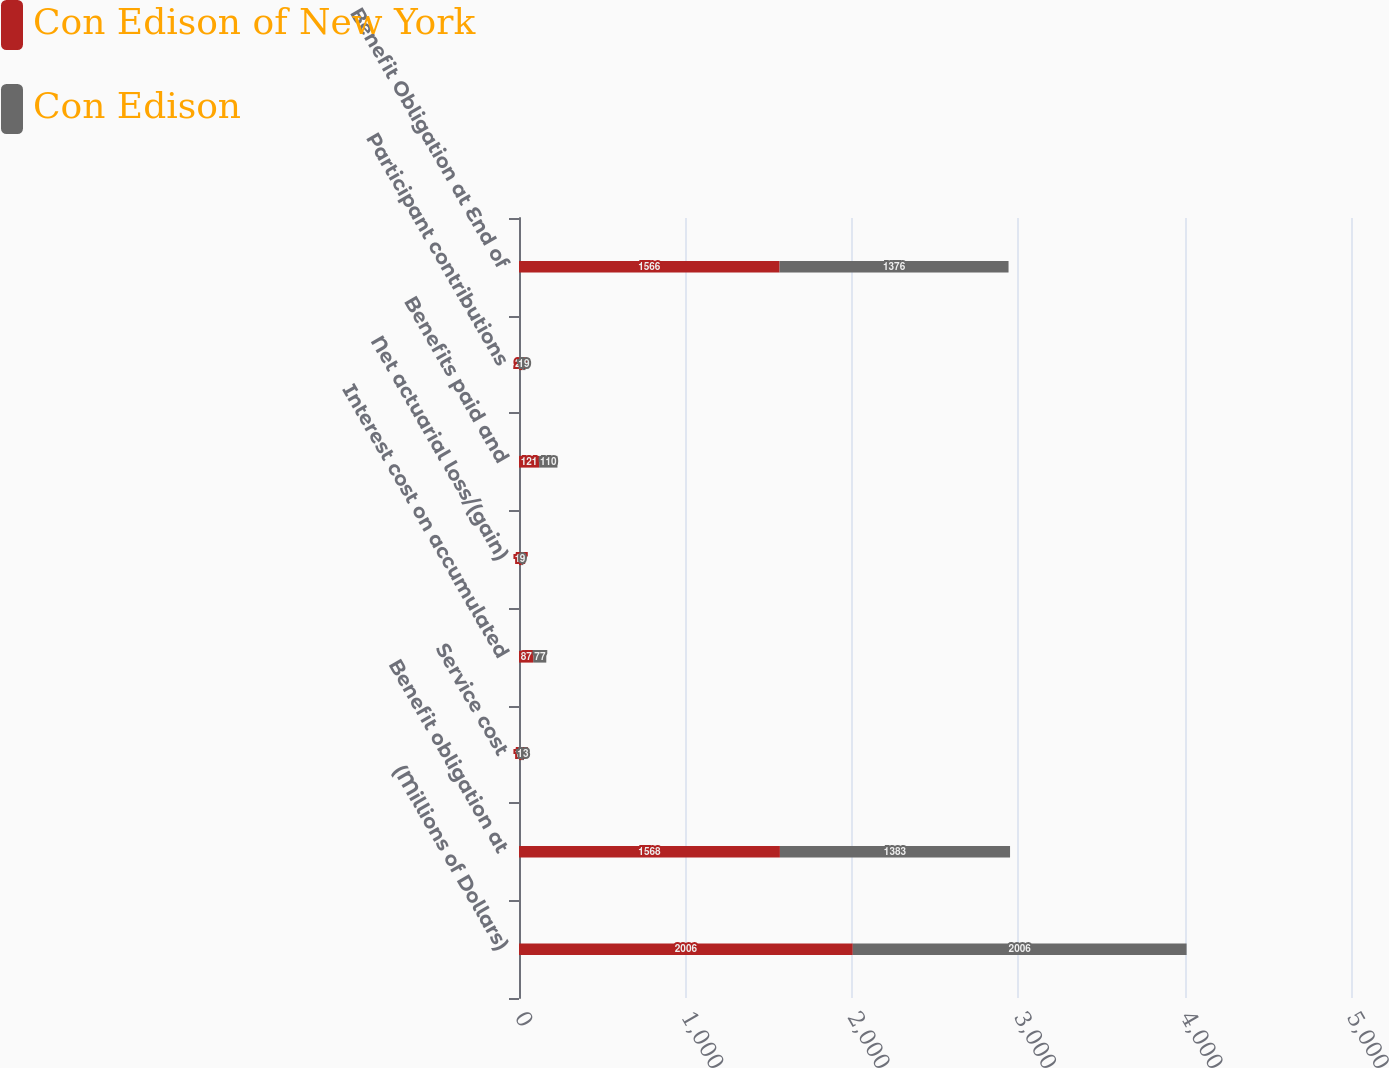<chart> <loc_0><loc_0><loc_500><loc_500><stacked_bar_chart><ecel><fcel>(Millions of Dollars)<fcel>Benefit obligation at<fcel>Service cost<fcel>Interest cost on accumulated<fcel>Net actuarial loss/(gain)<fcel>Benefits paid and<fcel>Participant contributions<fcel>Benefit Obligation at End of<nl><fcel>Con Edison of New York<fcel>2006<fcel>1568<fcel>17<fcel>87<fcel>17<fcel>121<fcel>20<fcel>1566<nl><fcel>Con Edison<fcel>2006<fcel>1383<fcel>13<fcel>77<fcel>9<fcel>110<fcel>19<fcel>1376<nl></chart> 